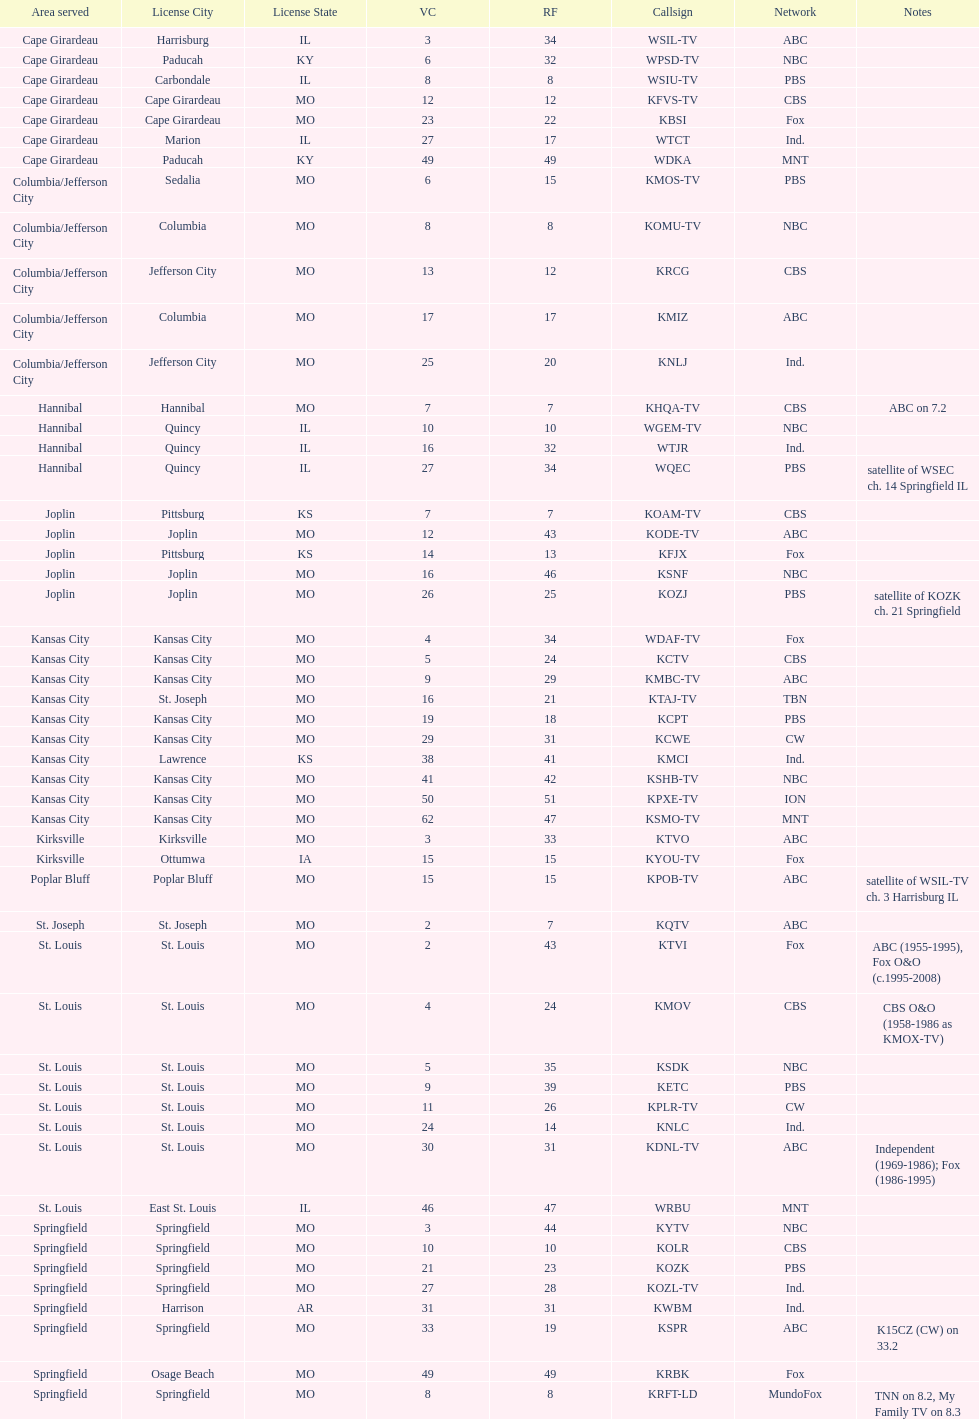Parse the table in full. {'header': ['Area served', 'License City', 'License State', 'VC', 'RF', 'Callsign', 'Network', 'Notes'], 'rows': [['Cape Girardeau', 'Harrisburg', 'IL', '3', '34', 'WSIL-TV', 'ABC', ''], ['Cape Girardeau', 'Paducah', 'KY', '6', '32', 'WPSD-TV', 'NBC', ''], ['Cape Girardeau', 'Carbondale', 'IL', '8', '8', 'WSIU-TV', 'PBS', ''], ['Cape Girardeau', 'Cape Girardeau', 'MO', '12', '12', 'KFVS-TV', 'CBS', ''], ['Cape Girardeau', 'Cape Girardeau', 'MO', '23', '22', 'KBSI', 'Fox', ''], ['Cape Girardeau', 'Marion', 'IL', '27', '17', 'WTCT', 'Ind.', ''], ['Cape Girardeau', 'Paducah', 'KY', '49', '49', 'WDKA', 'MNT', ''], ['Columbia/Jefferson City', 'Sedalia', 'MO', '6', '15', 'KMOS-TV', 'PBS', ''], ['Columbia/Jefferson City', 'Columbia', 'MO', '8', '8', 'KOMU-TV', 'NBC', ''], ['Columbia/Jefferson City', 'Jefferson City', 'MO', '13', '12', 'KRCG', 'CBS', ''], ['Columbia/Jefferson City', 'Columbia', 'MO', '17', '17', 'KMIZ', 'ABC', ''], ['Columbia/Jefferson City', 'Jefferson City', 'MO', '25', '20', 'KNLJ', 'Ind.', ''], ['Hannibal', 'Hannibal', 'MO', '7', '7', 'KHQA-TV', 'CBS', 'ABC on 7.2'], ['Hannibal', 'Quincy', 'IL', '10', '10', 'WGEM-TV', 'NBC', ''], ['Hannibal', 'Quincy', 'IL', '16', '32', 'WTJR', 'Ind.', ''], ['Hannibal', 'Quincy', 'IL', '27', '34', 'WQEC', 'PBS', 'satellite of WSEC ch. 14 Springfield IL'], ['Joplin', 'Pittsburg', 'KS', '7', '7', 'KOAM-TV', 'CBS', ''], ['Joplin', 'Joplin', 'MO', '12', '43', 'KODE-TV', 'ABC', ''], ['Joplin', 'Pittsburg', 'KS', '14', '13', 'KFJX', 'Fox', ''], ['Joplin', 'Joplin', 'MO', '16', '46', 'KSNF', 'NBC', ''], ['Joplin', 'Joplin', 'MO', '26', '25', 'KOZJ', 'PBS', 'satellite of KOZK ch. 21 Springfield'], ['Kansas City', 'Kansas City', 'MO', '4', '34', 'WDAF-TV', 'Fox', ''], ['Kansas City', 'Kansas City', 'MO', '5', '24', 'KCTV', 'CBS', ''], ['Kansas City', 'Kansas City', 'MO', '9', '29', 'KMBC-TV', 'ABC', ''], ['Kansas City', 'St. Joseph', 'MO', '16', '21', 'KTAJ-TV', 'TBN', ''], ['Kansas City', 'Kansas City', 'MO', '19', '18', 'KCPT', 'PBS', ''], ['Kansas City', 'Kansas City', 'MO', '29', '31', 'KCWE', 'CW', ''], ['Kansas City', 'Lawrence', 'KS', '38', '41', 'KMCI', 'Ind.', ''], ['Kansas City', 'Kansas City', 'MO', '41', '42', 'KSHB-TV', 'NBC', ''], ['Kansas City', 'Kansas City', 'MO', '50', '51', 'KPXE-TV', 'ION', ''], ['Kansas City', 'Kansas City', 'MO', '62', '47', 'KSMO-TV', 'MNT', ''], ['Kirksville', 'Kirksville', 'MO', '3', '33', 'KTVO', 'ABC', ''], ['Kirksville', 'Ottumwa', 'IA', '15', '15', 'KYOU-TV', 'Fox', ''], ['Poplar Bluff', 'Poplar Bluff', 'MO', '15', '15', 'KPOB-TV', 'ABC', 'satellite of WSIL-TV ch. 3 Harrisburg IL'], ['St. Joseph', 'St. Joseph', 'MO', '2', '7', 'KQTV', 'ABC', ''], ['St. Louis', 'St. Louis', 'MO', '2', '43', 'KTVI', 'Fox', 'ABC (1955-1995), Fox O&O (c.1995-2008)'], ['St. Louis', 'St. Louis', 'MO', '4', '24', 'KMOV', 'CBS', 'CBS O&O (1958-1986 as KMOX-TV)'], ['St. Louis', 'St. Louis', 'MO', '5', '35', 'KSDK', 'NBC', ''], ['St. Louis', 'St. Louis', 'MO', '9', '39', 'KETC', 'PBS', ''], ['St. Louis', 'St. Louis', 'MO', '11', '26', 'KPLR-TV', 'CW', ''], ['St. Louis', 'St. Louis', 'MO', '24', '14', 'KNLC', 'Ind.', ''], ['St. Louis', 'St. Louis', 'MO', '30', '31', 'KDNL-TV', 'ABC', 'Independent (1969-1986); Fox (1986-1995)'], ['St. Louis', 'East St. Louis', 'IL', '46', '47', 'WRBU', 'MNT', ''], ['Springfield', 'Springfield', 'MO', '3', '44', 'KYTV', 'NBC', ''], ['Springfield', 'Springfield', 'MO', '10', '10', 'KOLR', 'CBS', ''], ['Springfield', 'Springfield', 'MO', '21', '23', 'KOZK', 'PBS', ''], ['Springfield', 'Springfield', 'MO', '27', '28', 'KOZL-TV', 'Ind.', ''], ['Springfield', 'Harrison', 'AR', '31', '31', 'KWBM', 'Ind.', ''], ['Springfield', 'Springfield', 'MO', '33', '19', 'KSPR', 'ABC', 'K15CZ (CW) on 33.2'], ['Springfield', 'Osage Beach', 'MO', '49', '49', 'KRBK', 'Fox', ''], ['Springfield', 'Springfield', 'MO', '8', '8', 'KRFT-LD', 'MundoFox', 'TNN on 8.2, My Family TV on 8.3']]} What is the total number of stations under the cbs network? 7. 